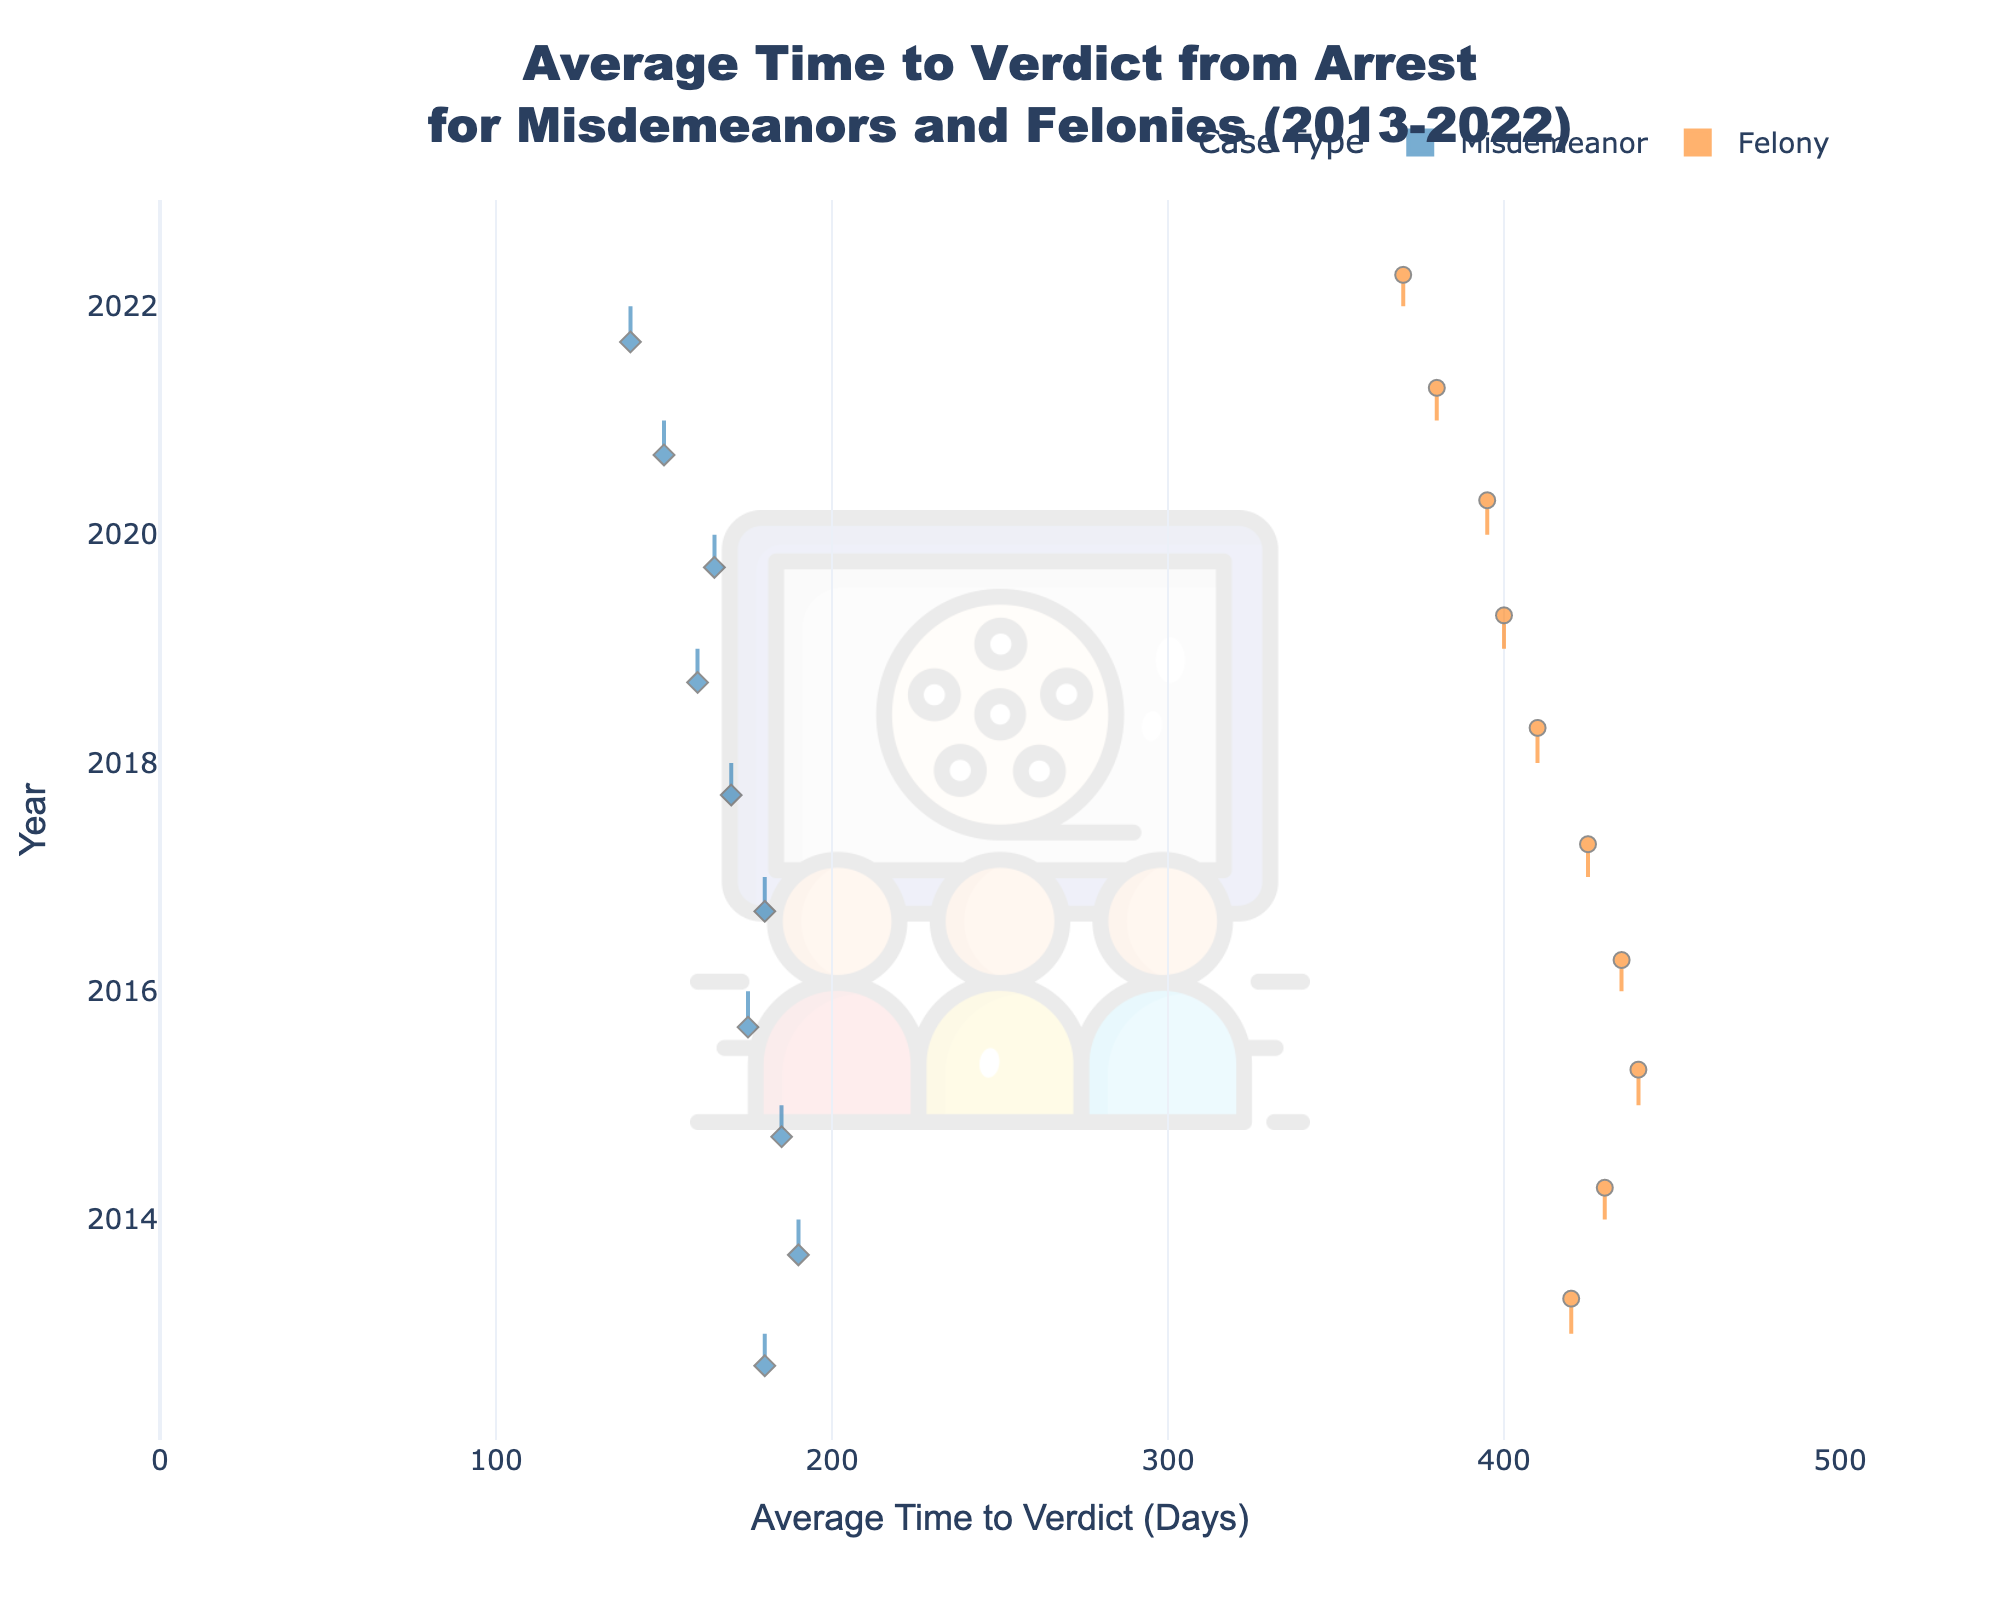What is the average time to verdict for misdemeanors in 2022? The figure shows the average time to verdict for misdemeanors in 2022 as a specific data point on the x-axis associated with the year 2022 on the y-axis. This value is approximately 140 days.
Answer: 140 days What color represents felonies on the chart? The violin plot uses two distinct colors to differentiate between misdemeanors and felonies. Felonies are represented with an orange color, while misdemeanors are in blue.
Answer: Orange How has the average time to verdict for felonies changed from 2013 to 2022? Observing the position of the relevant data points and the shape of the violins representing felonies, we notice a downward trend in the average time to verdict from around 420 days in 2013 to approximately 370 days in 2022.
Answer: Decreased Which case type shows a larger spread in the average time to verdict, misdemeanors or felonies? By comparing the shapes of the two violin plots, felonies show a larger spread in their average time to verdict because the violin plot for felonies has a wider range and more variation along the x-axis compared to misdemeanors.
Answer: Felonies During which years did misdemeanors have an average time to verdict of less than 160 days? Referencing the data points within the misdemeanor violin plot, years 2019, 2020, 2021, and 2022 have average times to verdict of less than 160 days.
Answer: 2019, 2020, 2021, 2022 What was the overall trend for the average time to verdict for misdemeanors from 2013 to 2022? Observing the trend line formed by the position of data points, the average time to verdict for misdemeanors generally decreased from 180 days in 2013 to 140 days in 2022.
Answer: Decreasing Which year had the smallest difference in the average time to verdict between misdemeanors and felonies? By comparing visually, the year with the smallest difference in average time to verdict between misdemeanors and felonies is 2022, where the average times are 140 days for misdemeanors and 370 days for felonies, resulting in a difference of 230 days, which is the smallest observed.
Answer: 2022 How does the distribution of the average time to verdict for felonies appear compared to misdemeanors? The felonies show a broader distribution with more variability, visible as a wider and more spread-out violin plot compared to the more compact and narrower distribution for misdemeanors.
Answer: Broader and more variable for felonies What is the median year for the average time to verdict data shown for felonies? Since we have data from 2013 to 2022, the median year would be the middle year in this sequence. The median year for the data points is 2017.
Answer: 2017 